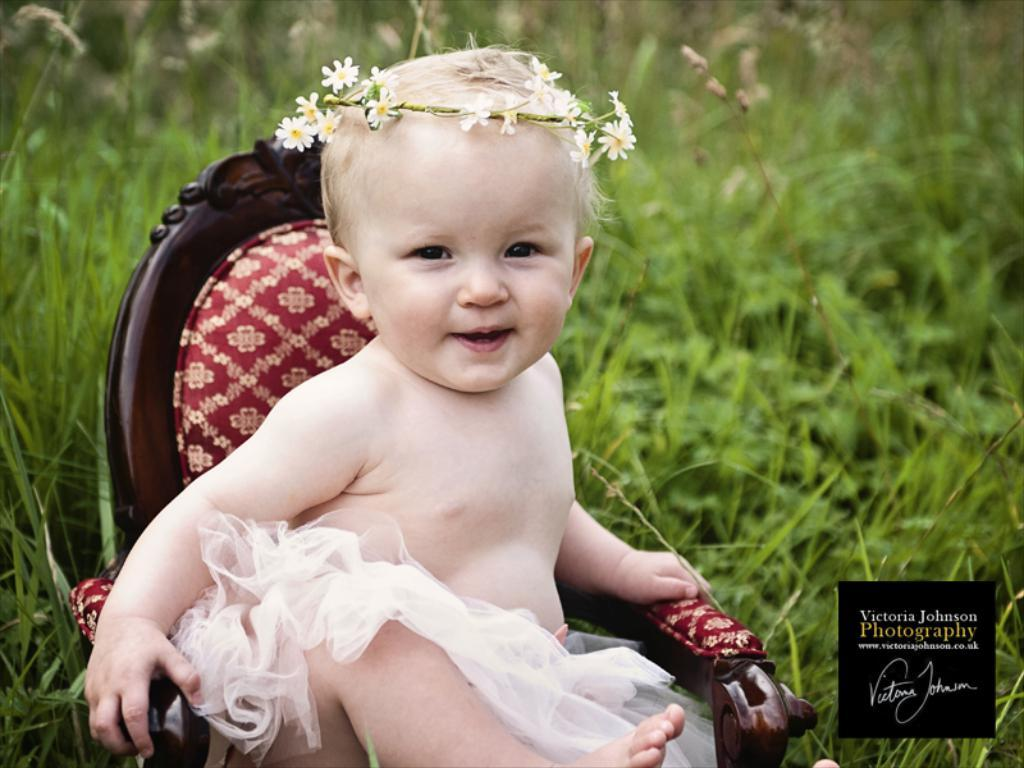What is the main subject of the picture? The main subject of the picture is a baby. What is the baby doing in the picture? The baby is sitting on a chair. What type of environment is visible in the picture? The surrounding area is full of grass. What type of animal can be seen in the background of the picture at the zoo? There is no mention of a zoo or any animals in the image, so it cannot be determined if any animals are present. 